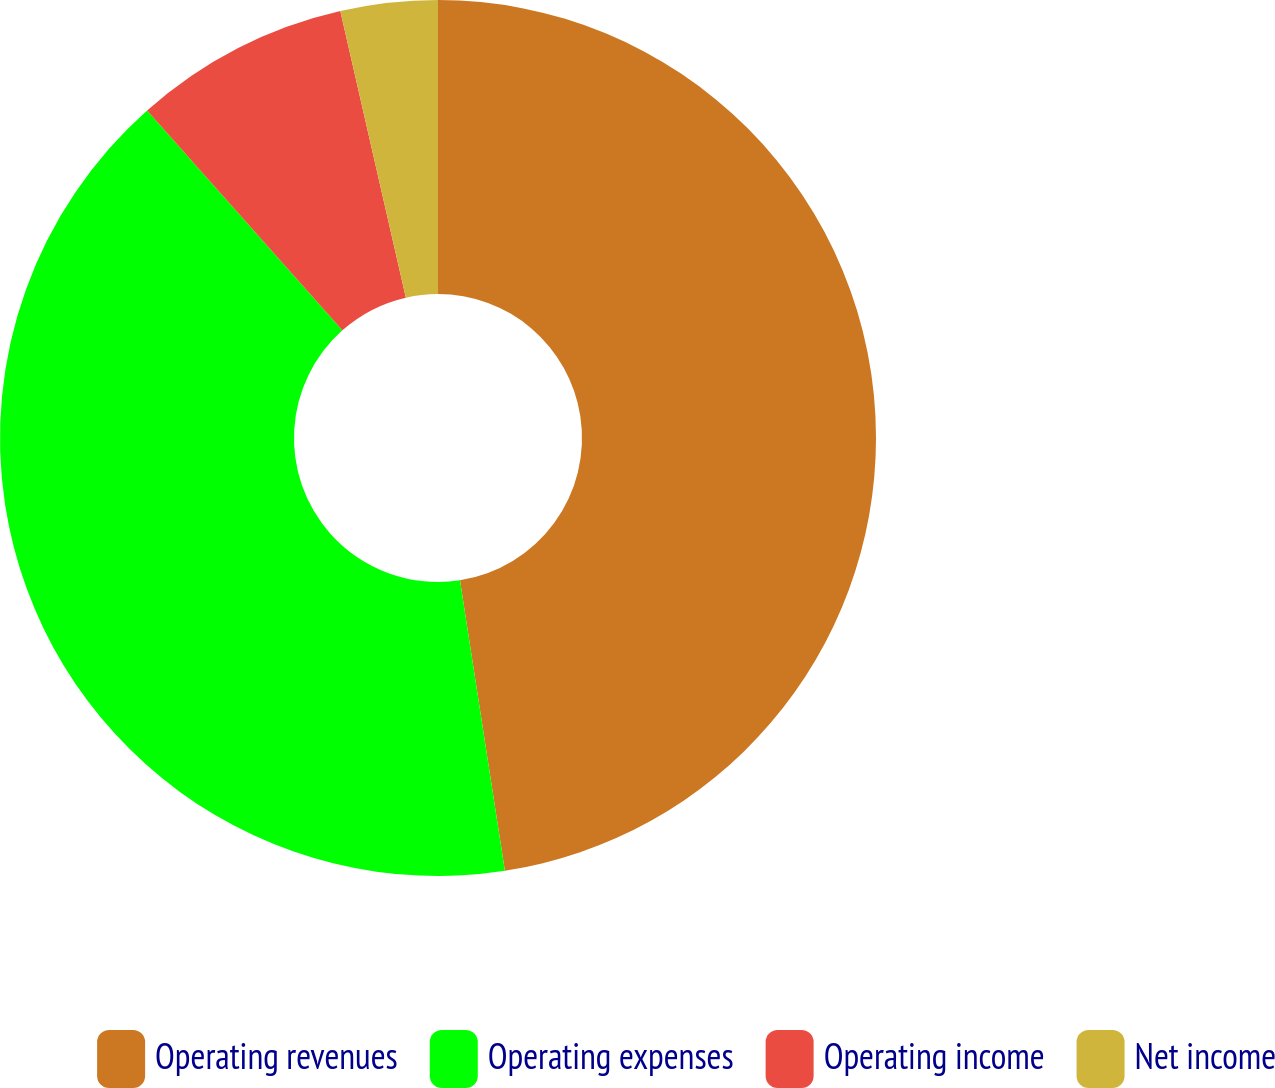<chart> <loc_0><loc_0><loc_500><loc_500><pie_chart><fcel>Operating revenues<fcel>Operating expenses<fcel>Operating income<fcel>Net income<nl><fcel>47.56%<fcel>40.88%<fcel>7.98%<fcel>3.58%<nl></chart> 